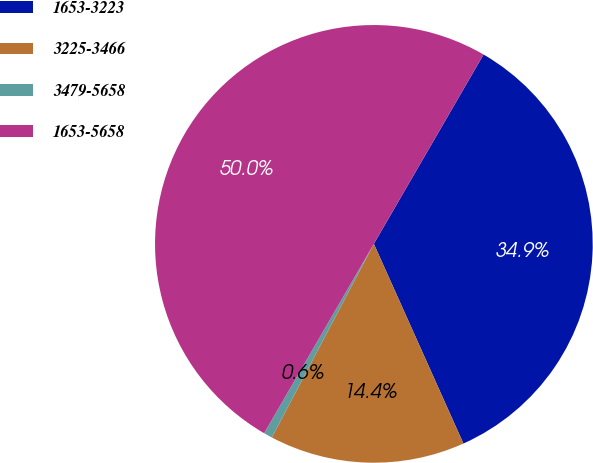<chart> <loc_0><loc_0><loc_500><loc_500><pie_chart><fcel>1653-3223<fcel>3225-3466<fcel>3479-5658<fcel>1653-5658<nl><fcel>34.93%<fcel>14.43%<fcel>0.64%<fcel>50.0%<nl></chart> 